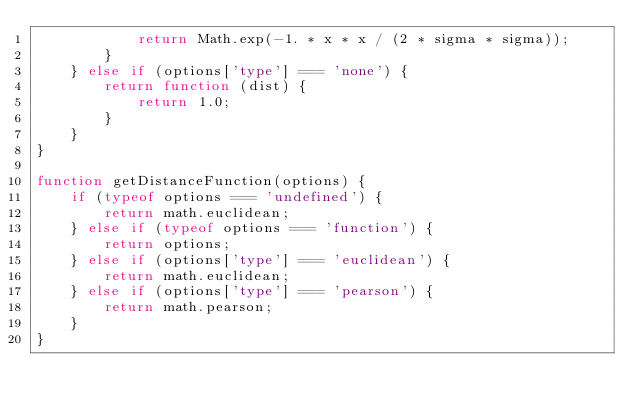Convert code to text. <code><loc_0><loc_0><loc_500><loc_500><_JavaScript_>            return Math.exp(-1. * x * x / (2 * sigma * sigma));
        }
    } else if (options['type'] === 'none') {
        return function (dist) {
            return 1.0;
        }
    }
}

function getDistanceFunction(options) {
    if (typeof options === 'undefined') {
        return math.euclidean;
    } else if (typeof options === 'function') {
        return options;
    } else if (options['type'] === 'euclidean') {
        return math.euclidean;
    } else if (options['type'] === 'pearson') {
        return math.pearson;
    }
}
</code> 